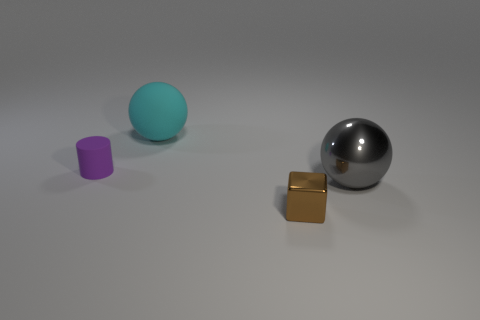How many yellow things are either small blocks or matte spheres?
Your answer should be very brief. 0. What number of things are tiny yellow objects or small things that are right of the cyan object?
Keep it short and to the point. 1. What is the large ball that is behind the large shiny sphere made of?
Your answer should be compact. Rubber. What is the shape of the other shiny object that is the same size as the cyan thing?
Give a very brief answer. Sphere. Are there any other large cyan things of the same shape as the cyan thing?
Make the answer very short. No. Does the large cyan object have the same material as the small object that is on the right side of the purple rubber object?
Provide a succinct answer. No. The large ball behind the tiny thing behind the gray metal ball is made of what material?
Offer a terse response. Rubber. Is the number of small rubber cylinders that are to the right of the block greater than the number of yellow cylinders?
Make the answer very short. No. Are there any blue shiny balls?
Offer a terse response. No. There is a big metallic object in front of the large cyan matte ball; what is its color?
Ensure brevity in your answer.  Gray. 